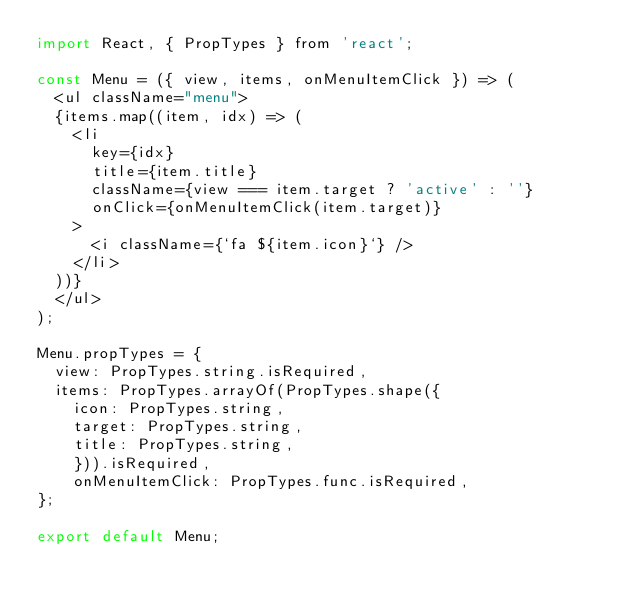<code> <loc_0><loc_0><loc_500><loc_500><_JavaScript_>import React, { PropTypes } from 'react';

const Menu = ({ view, items, onMenuItemClick }) => (
	<ul className="menu">
	{items.map((item, idx) => (
		<li
			key={idx}
			title={item.title}
			className={view === item.target ? 'active' : ''}
			onClick={onMenuItemClick(item.target)}
		>
			<i className={`fa ${item.icon}`} />
		</li>
	))}
	</ul>
);

Menu.propTypes = {
	view: PropTypes.string.isRequired,
	items: PropTypes.arrayOf(PropTypes.shape({
		icon: PropTypes.string,
		target: PropTypes.string,
		title: PropTypes.string,
    })).isRequired,
    onMenuItemClick: PropTypes.func.isRequired,
};

export default Menu;</code> 